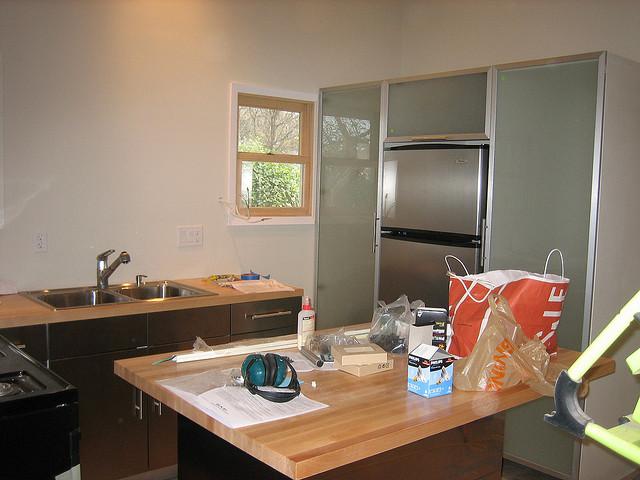What color is the counter?
Answer briefly. Brown. What is in the bag on table in foreground?
Keep it brief. Food. Is the plastic bag recyclable?
Keep it brief. No. Is the fridge open?
Give a very brief answer. No. 